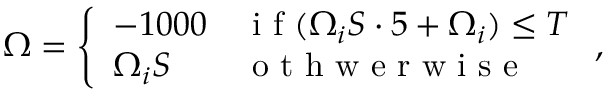Convert formula to latex. <formula><loc_0><loc_0><loc_500><loc_500>\Omega = \left \{ \begin{array} { l l } { - 1 0 0 0 } & { i f ( \Omega _ { i } S \cdot 5 + \Omega _ { i } ) \leq T } \\ { \Omega _ { i } S } & { o t h w e r w i s e } \end{array} ,</formula> 